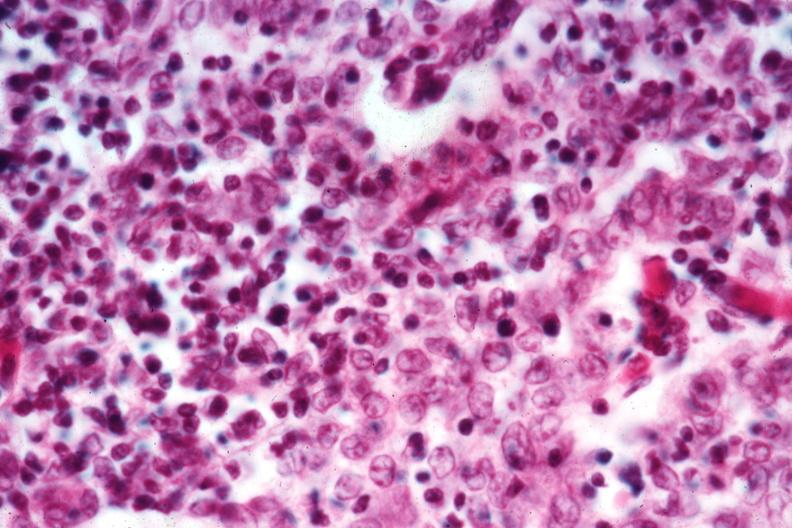s thymoma present?
Answer the question using a single word or phrase. Yes 